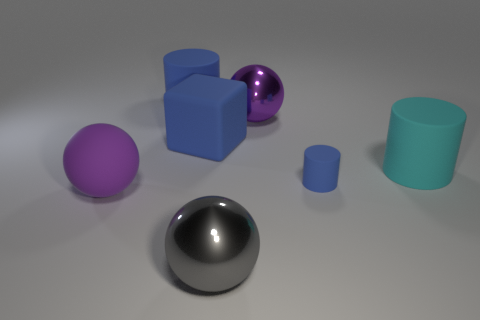How many objects are there in the picture, and can you describe their colors and shapes? There are six objects in the picture. Starting from the left, we have a purple sphere, two blue cubes - one larger and one smaller, a shiny purple sphere, a large cyan cylinder, and a smaller blue cylinder. Their shapes range from spherical to cubic and cylindrical. 